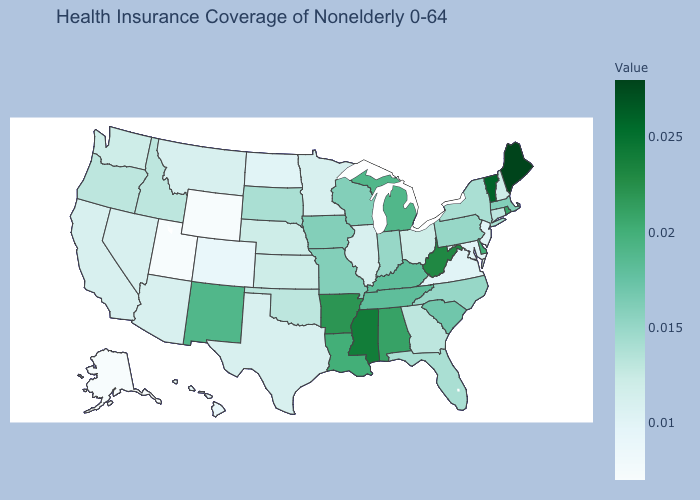Is the legend a continuous bar?
Keep it brief. Yes. Among the states that border New Hampshire , does Vermont have the highest value?
Quick response, please. No. Among the states that border Wisconsin , which have the lowest value?
Be succinct. Illinois, Minnesota. Among the states that border Oklahoma , which have the highest value?
Keep it brief. Arkansas. Among the states that border Minnesota , which have the highest value?
Short answer required. Iowa, Wisconsin. Which states hav the highest value in the South?
Keep it brief. Mississippi. Among the states that border Idaho , does Utah have the lowest value?
Concise answer only. Yes. Among the states that border Connecticut , which have the highest value?
Keep it brief. Rhode Island. Does Vermont have the lowest value in the Northeast?
Write a very short answer. No. Is the legend a continuous bar?
Give a very brief answer. Yes. Does South Carolina have the lowest value in the USA?
Keep it brief. No. Does Delaware have a higher value than Iowa?
Answer briefly. Yes. 